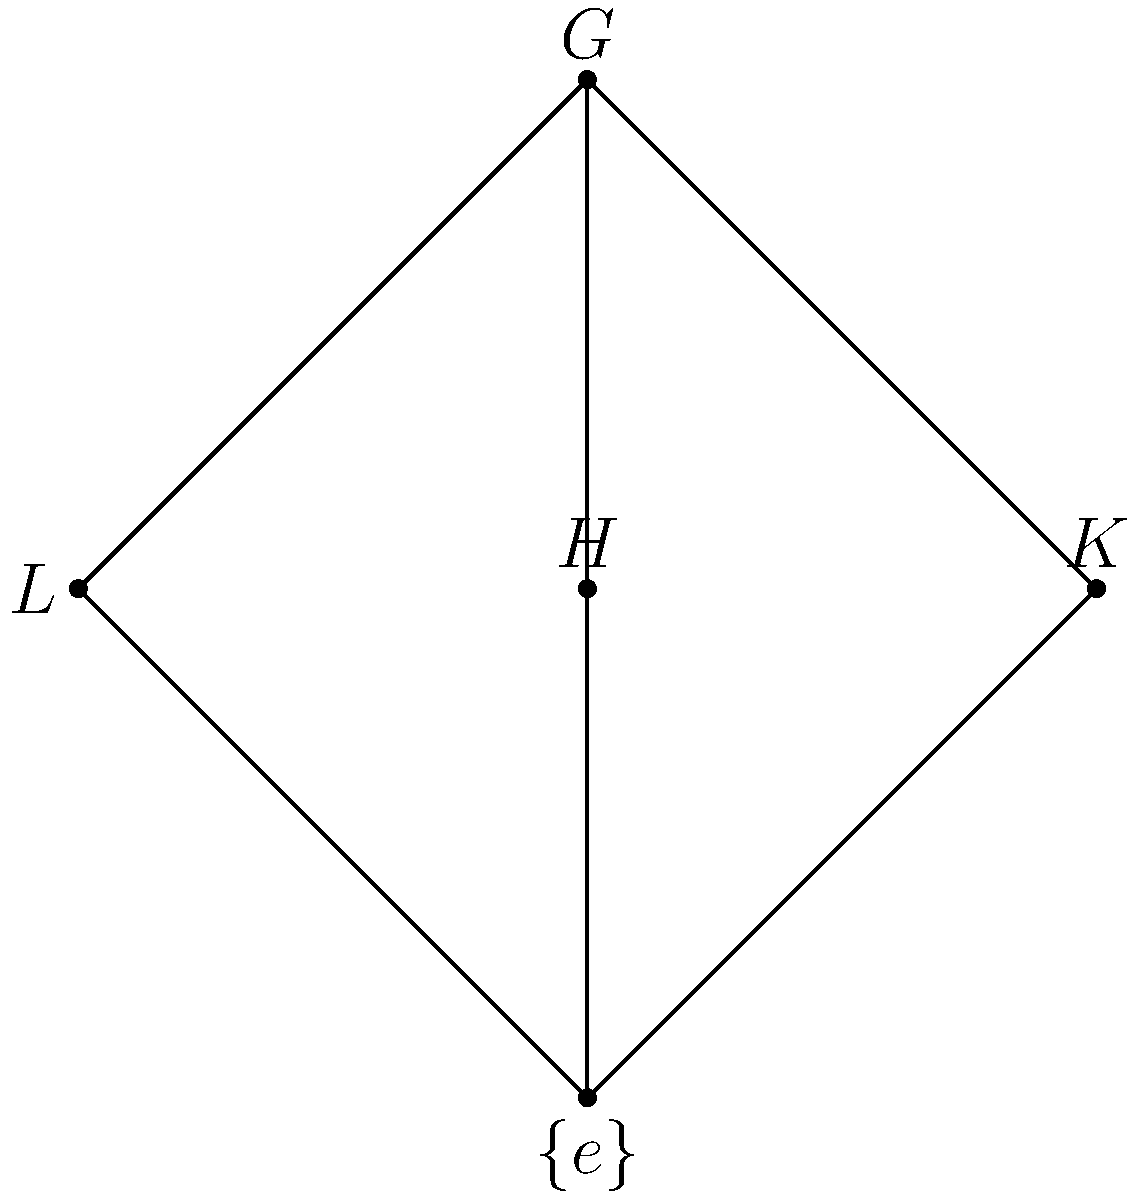Given the subgroup lattice diagram of a group $G$, where $H$, $K$, and $L$ are proper subgroups of $G$, and $\{e\}$ is the trivial subgroup, determine the order of group $G$ if $|H| = 4$ and $|K| = 3$. To solve this problem, we'll follow these steps:

1) In a subgroup lattice, subgroups higher in the diagram contain those below them.

2) $H$ and $K$ are maximal subgroups (directly below $G$), and they intersect at the trivial subgroup $\{e\}$.

3) By Lagrange's theorem, the order of any subgroup must divide the order of the group.

4) Since $|H| = 4$ and $|K| = 3$, we know that $|G|$ must be divisible by both 4 and 3.

5) The least common multiple of 4 and 3 is 12.

6) Given that $H$ and $K$ are maximal and their intersection is trivial, $G$ must be the direct product of $H$ and $K$.

7) Therefore, $|G| = |H| \times |K| = 4 \times 3 = 12$.

This structure is consistent with the group $G = C_4 \times C_3 \cong C_{12}$, where $C_n$ denotes the cyclic group of order $n$.
Answer: 12 